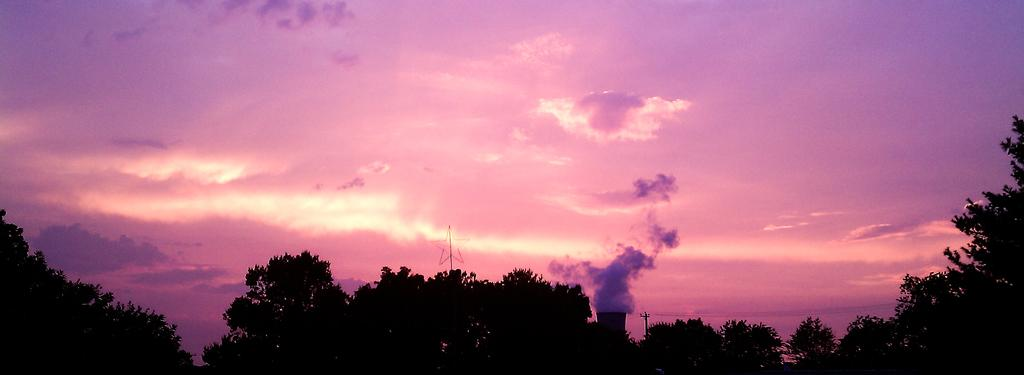What is the main feature of the landscape in the image? There are many trees in the image. What man-made structure can be seen in the image? There is an electrical pole with wires in the image. What is happening at the tower in the image? The tower has smoke coming from it. What celestial object is visible in the image? There is a star visible in the image. What can be seen in the background of the image? The sky is visible in the background of the image. What is the weather like in the image? The presence of clouds in the sky suggests that it might be partly cloudy. What type of lettuce is being used to create acoustics in the image? There is no lettuce present in the image, and therefore no such acoustic effect can be observed. Can you see a zebra grazing among the trees in the image? There is no zebra present in the image; it features trees, an electrical pole with wires, a tower with smoke, a star, and clouds in the sky. 